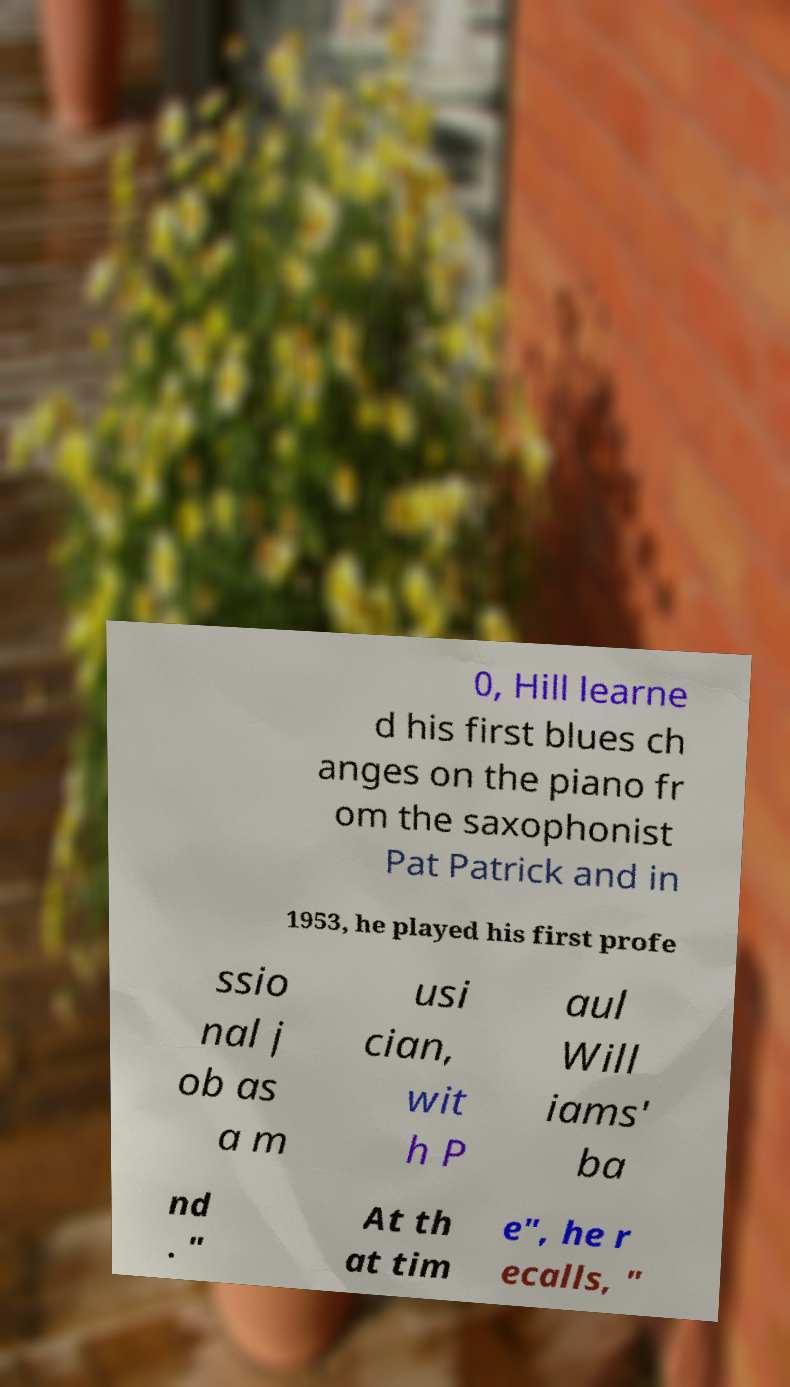Can you read and provide the text displayed in the image?This photo seems to have some interesting text. Can you extract and type it out for me? 0, Hill learne d his first blues ch anges on the piano fr om the saxophonist Pat Patrick and in 1953, he played his first profe ssio nal j ob as a m usi cian, wit h P aul Will iams' ba nd . " At th at tim e", he r ecalls, " 